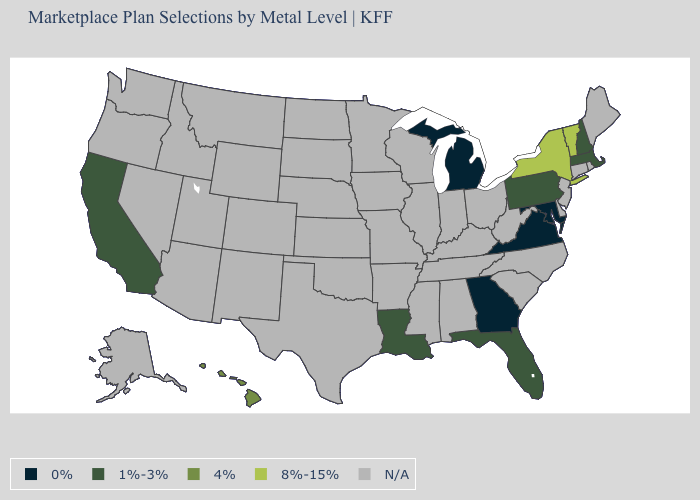Name the states that have a value in the range 8%-15%?
Keep it brief. New York, Vermont. Among the states that border Ohio , which have the lowest value?
Be succinct. Michigan. What is the value of New Jersey?
Write a very short answer. N/A. What is the value of Wisconsin?
Answer briefly. N/A. Name the states that have a value in the range 0%?
Give a very brief answer. Georgia, Maryland, Michigan, Virginia. What is the value of Michigan?
Give a very brief answer. 0%. What is the value of Colorado?
Write a very short answer. N/A. Does the map have missing data?
Give a very brief answer. Yes. What is the value of Illinois?
Be succinct. N/A. Name the states that have a value in the range 8%-15%?
Write a very short answer. New York, Vermont. Is the legend a continuous bar?
Short answer required. No. Name the states that have a value in the range 4%?
Give a very brief answer. Hawaii. 